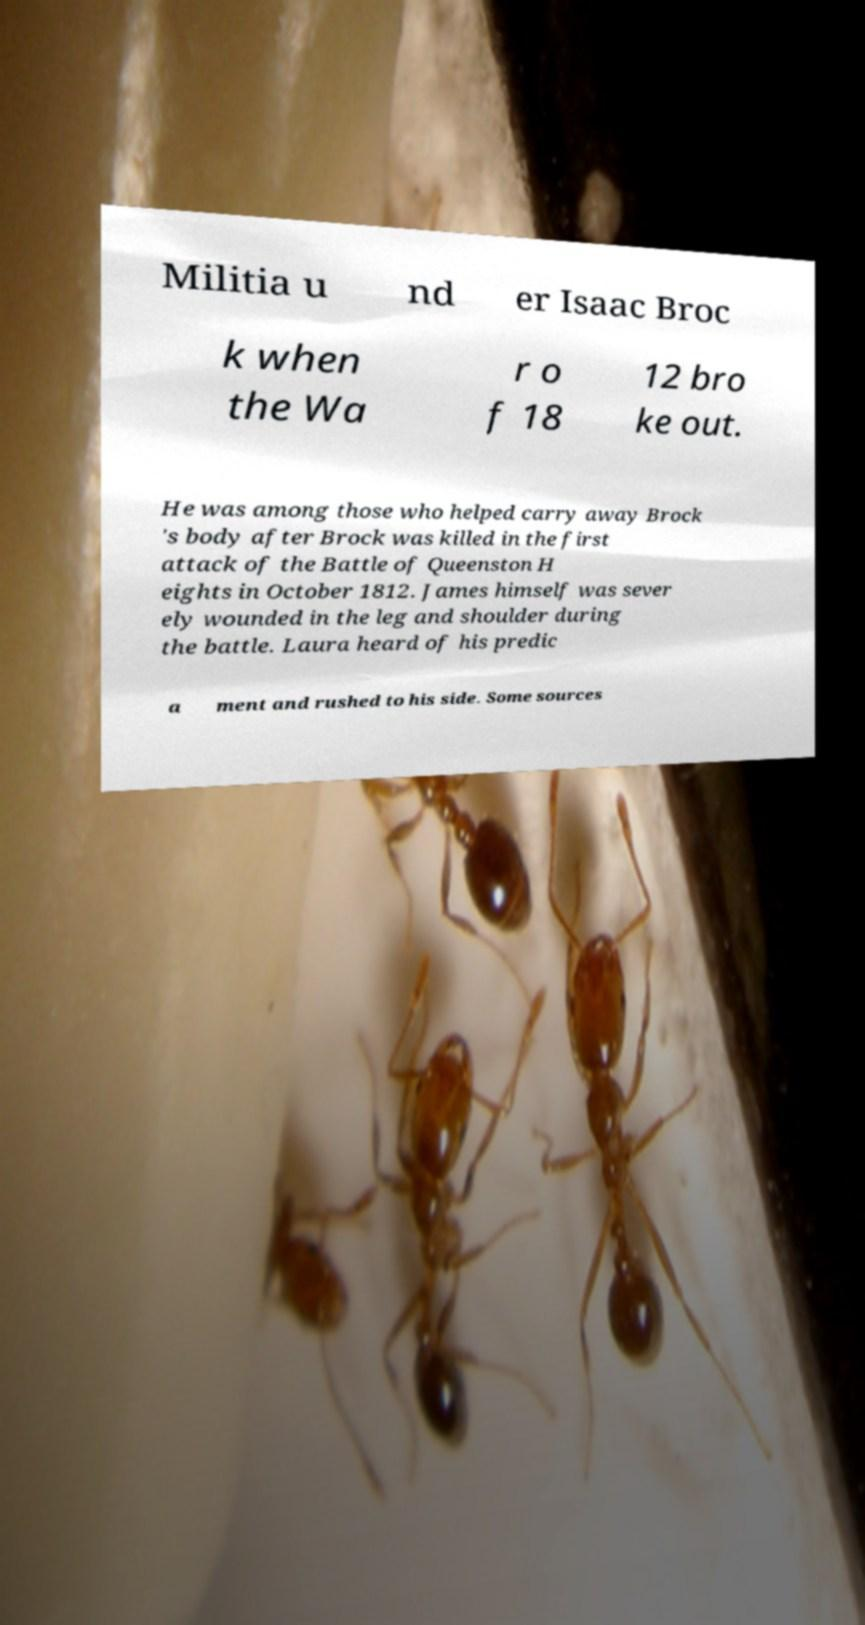There's text embedded in this image that I need extracted. Can you transcribe it verbatim? Militia u nd er Isaac Broc k when the Wa r o f 18 12 bro ke out. He was among those who helped carry away Brock 's body after Brock was killed in the first attack of the Battle of Queenston H eights in October 1812. James himself was sever ely wounded in the leg and shoulder during the battle. Laura heard of his predic a ment and rushed to his side. Some sources 